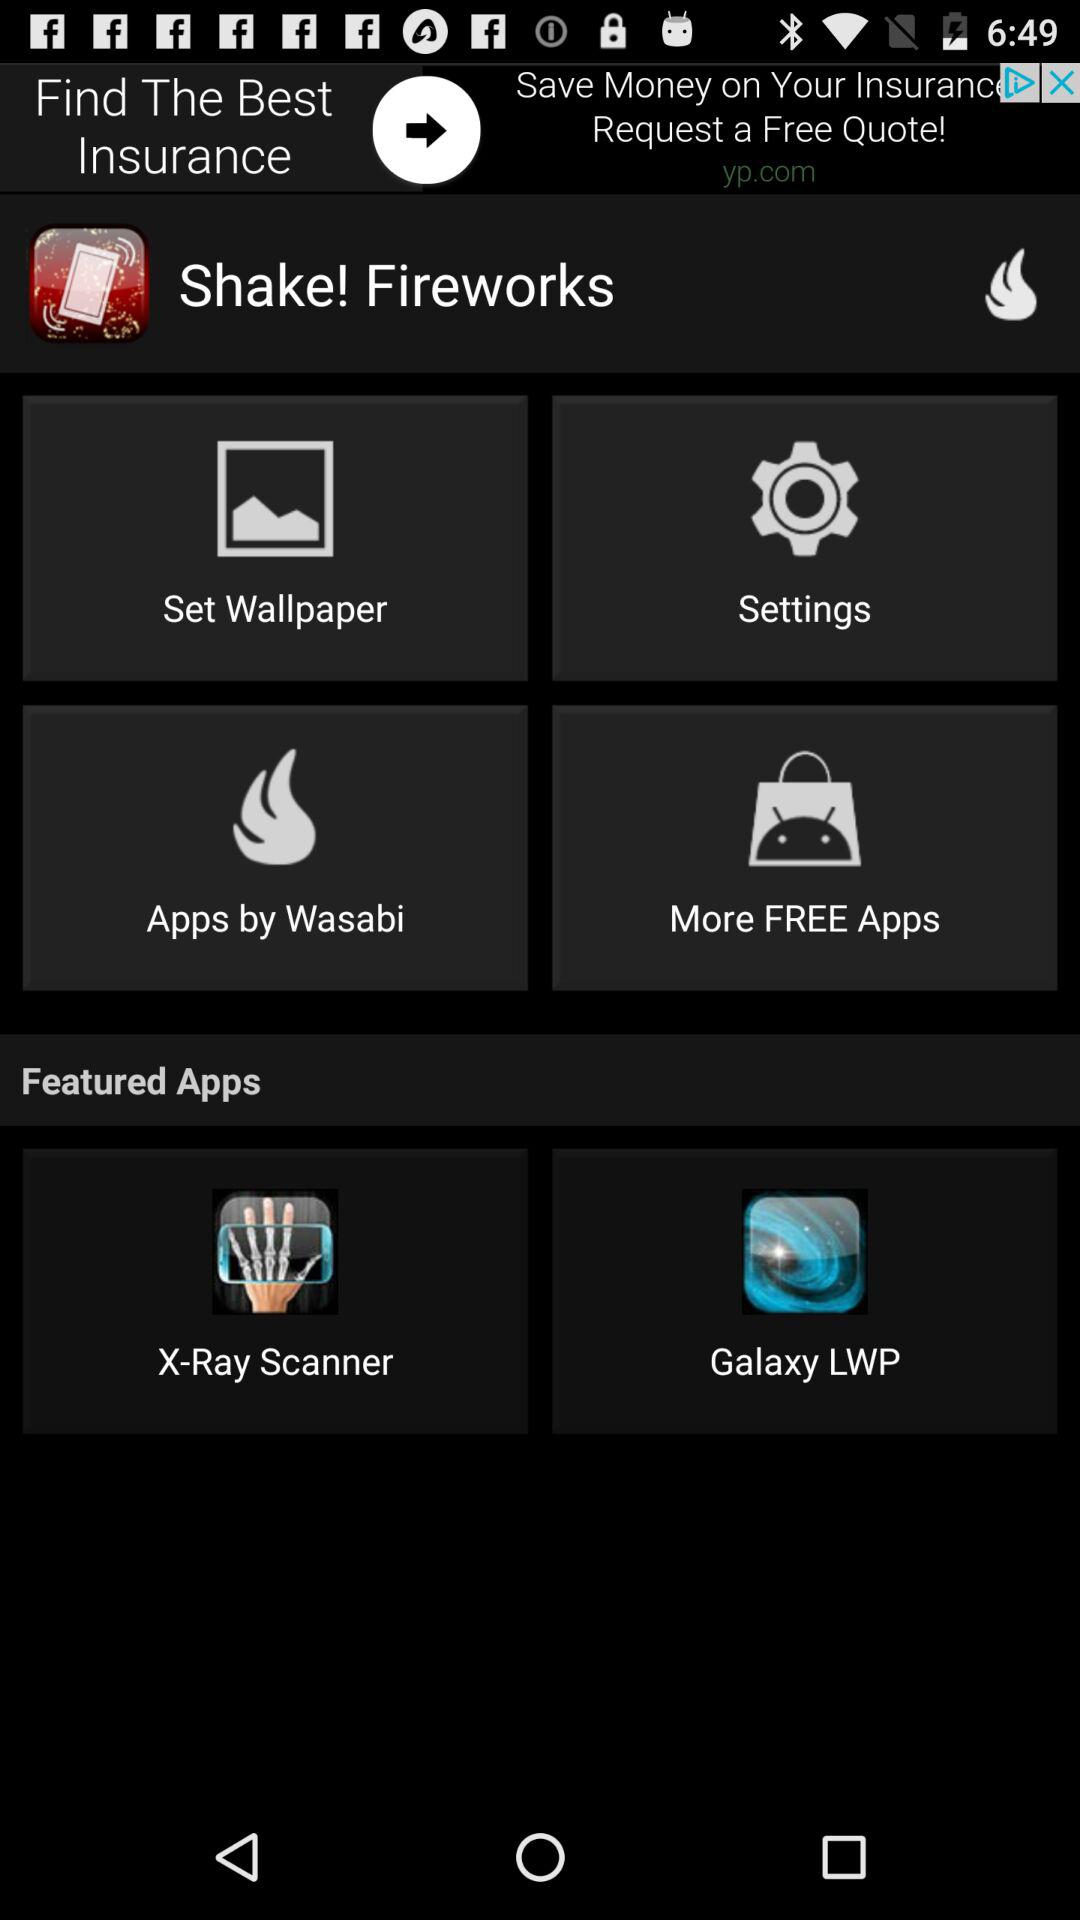What is the name of the application? The names of the applications are "Shake! Fireworks", "X-Ray Scanner" and "Galaxy LWP". 